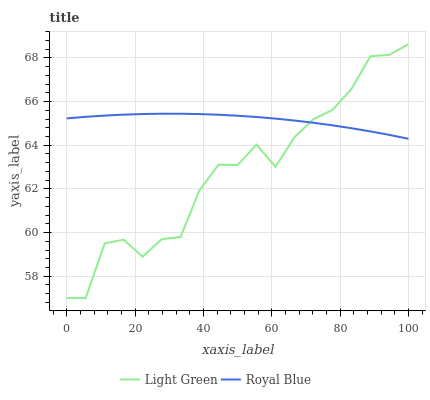Does Light Green have the minimum area under the curve?
Answer yes or no. Yes. Does Royal Blue have the maximum area under the curve?
Answer yes or no. Yes. Does Light Green have the maximum area under the curve?
Answer yes or no. No. Is Royal Blue the smoothest?
Answer yes or no. Yes. Is Light Green the roughest?
Answer yes or no. Yes. Is Light Green the smoothest?
Answer yes or no. No. Does Light Green have the lowest value?
Answer yes or no. Yes. Does Light Green have the highest value?
Answer yes or no. Yes. Does Light Green intersect Royal Blue?
Answer yes or no. Yes. Is Light Green less than Royal Blue?
Answer yes or no. No. Is Light Green greater than Royal Blue?
Answer yes or no. No. 